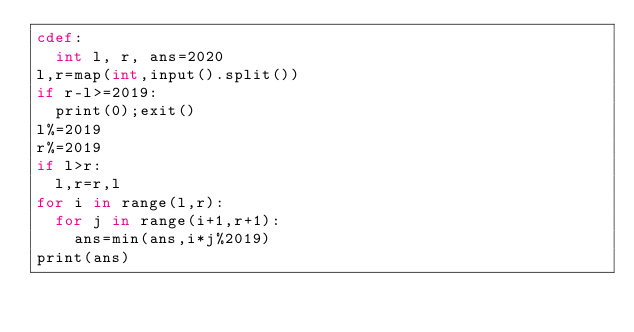Convert code to text. <code><loc_0><loc_0><loc_500><loc_500><_Cython_>cdef:
  int l, r, ans=2020
l,r=map(int,input().split())
if r-l>=2019:
  print(0);exit()
l%=2019
r%=2019
if l>r:
  l,r=r,l
for i in range(l,r):
  for j in range(i+1,r+1):
    ans=min(ans,i*j%2019)
print(ans)</code> 